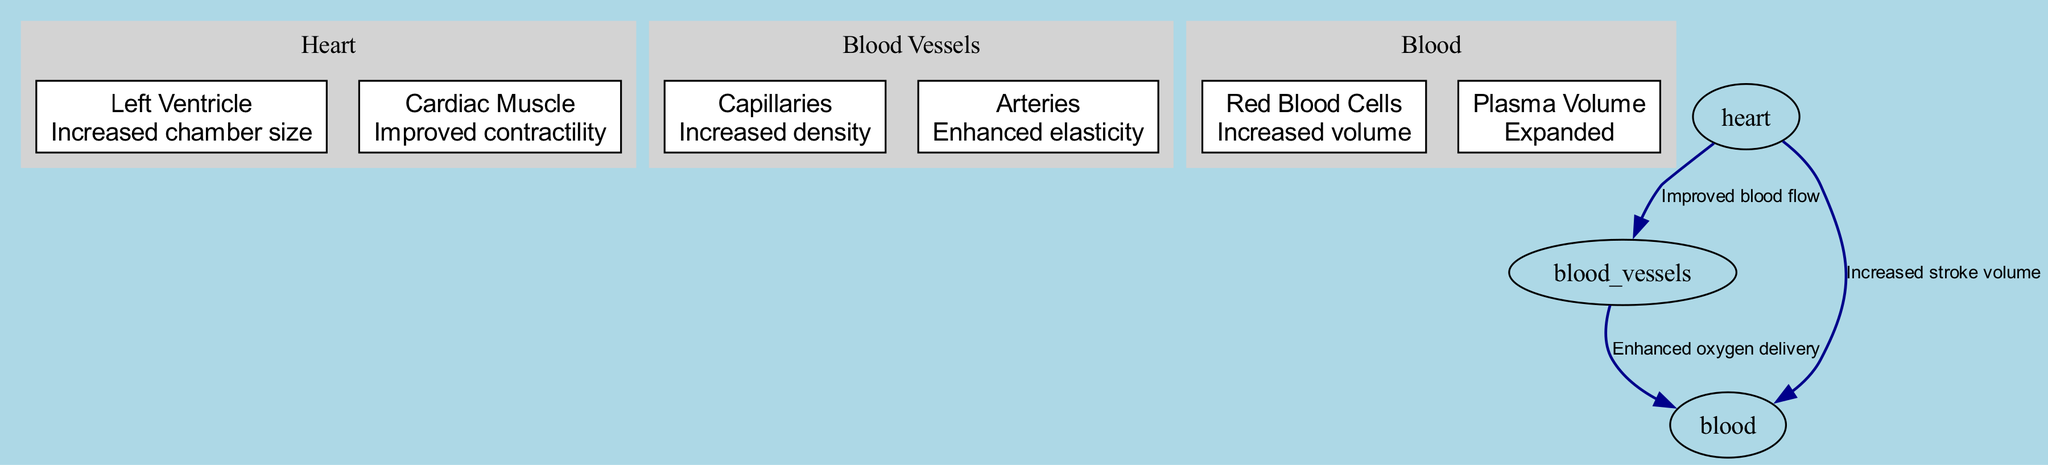What are the components of the heart shown in the diagram? The heart has two components displayed: the Left Ventricle, which has the description "Increased chamber size," and the Cardiac Muscle, which is described as "Improved contractility."
Answer: Left Ventricle, Cardiac Muscle What change occurs to blood vessels during endurance training? The blood vessels demonstrate two changes: the Capillaries have "Increased density," and the Arteries exhibit "Enhanced elasticity."
Answer: Increased density, Enhanced elasticity How does the heart affect blood flow to the vessels? The diagram indicates that the heart improves blood flow to the blood vessels, as noted by the edge labeled "Improved blood flow."
Answer: Improved blood flow Which blood component has increased volume as an adaptation? The adaptation shows that Red Blood Cells experience "Increased volume," which is specified in the blood component of the diagram.
Answer: Increased volume What effect does the heart have on stroke volume? The diagram states that the heart leads to an "Increased stroke volume," ensuring effective pumping of the blood.
Answer: Increased stroke volume What is the relationship between arteries and blood in the diagram? The arteries have an edge leading to blood which indicates "Enhanced oxygen delivery," establishing a functional link regarding oxygenation.
Answer: Enhanced oxygen delivery How many nodes are present in the blood section of the diagram? The blood section contains two nodes: the Red Blood Cells and Plasma Volume, thus providing a total of two distinct components.
Answer: 2 How many edges connect the heart to other components in the diagram? The heart is connected to three other components via edges: to blood vessels, to blood, and indicating improved blood flow, giving a total count of three edges.
Answer: 3 What does the diagram suggest about capillary density in response to training? The capillary density is described as "Increased density," indicating a significant change due to endurance training adaptations reflected in the diagram.
Answer: Increased density 